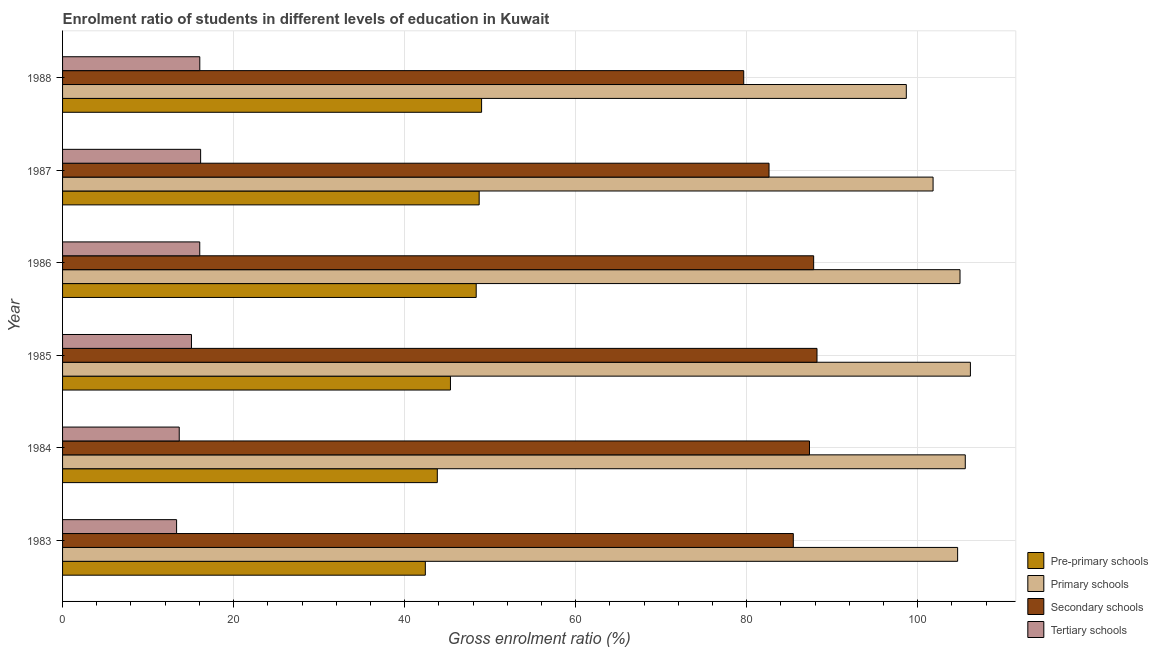How many different coloured bars are there?
Offer a terse response. 4. How many groups of bars are there?
Ensure brevity in your answer.  6. Are the number of bars per tick equal to the number of legend labels?
Give a very brief answer. Yes. What is the gross enrolment ratio in secondary schools in 1984?
Ensure brevity in your answer.  87.34. Across all years, what is the maximum gross enrolment ratio in pre-primary schools?
Your answer should be compact. 49. Across all years, what is the minimum gross enrolment ratio in secondary schools?
Offer a terse response. 79.65. In which year was the gross enrolment ratio in tertiary schools minimum?
Your response must be concise. 1983. What is the total gross enrolment ratio in tertiary schools in the graph?
Ensure brevity in your answer.  90.28. What is the difference between the gross enrolment ratio in tertiary schools in 1983 and that in 1985?
Your response must be concise. -1.74. What is the difference between the gross enrolment ratio in tertiary schools in 1985 and the gross enrolment ratio in secondary schools in 1983?
Provide a succinct answer. -70.38. What is the average gross enrolment ratio in secondary schools per year?
Offer a terse response. 85.18. In the year 1985, what is the difference between the gross enrolment ratio in primary schools and gross enrolment ratio in secondary schools?
Make the answer very short. 17.94. What is the ratio of the gross enrolment ratio in pre-primary schools in 1985 to that in 1986?
Give a very brief answer. 0.94. Is the gross enrolment ratio in secondary schools in 1985 less than that in 1986?
Ensure brevity in your answer.  No. Is the difference between the gross enrolment ratio in pre-primary schools in 1983 and 1988 greater than the difference between the gross enrolment ratio in primary schools in 1983 and 1988?
Offer a very short reply. No. What is the difference between the highest and the second highest gross enrolment ratio in tertiary schools?
Your answer should be very brief. 0.1. What is the difference between the highest and the lowest gross enrolment ratio in primary schools?
Your answer should be compact. 7.49. Is it the case that in every year, the sum of the gross enrolment ratio in secondary schools and gross enrolment ratio in pre-primary schools is greater than the sum of gross enrolment ratio in tertiary schools and gross enrolment ratio in primary schools?
Provide a short and direct response. No. What does the 4th bar from the top in 1986 represents?
Keep it short and to the point. Pre-primary schools. What does the 3rd bar from the bottom in 1987 represents?
Your answer should be very brief. Secondary schools. Is it the case that in every year, the sum of the gross enrolment ratio in pre-primary schools and gross enrolment ratio in primary schools is greater than the gross enrolment ratio in secondary schools?
Your answer should be compact. Yes. How many bars are there?
Your answer should be very brief. 24. Are all the bars in the graph horizontal?
Provide a short and direct response. Yes. Are the values on the major ticks of X-axis written in scientific E-notation?
Your answer should be compact. No. Does the graph contain grids?
Ensure brevity in your answer.  Yes. How are the legend labels stacked?
Your answer should be compact. Vertical. What is the title of the graph?
Your response must be concise. Enrolment ratio of students in different levels of education in Kuwait. What is the label or title of the X-axis?
Keep it short and to the point. Gross enrolment ratio (%). What is the Gross enrolment ratio (%) of Pre-primary schools in 1983?
Your answer should be very brief. 42.42. What is the Gross enrolment ratio (%) in Primary schools in 1983?
Provide a short and direct response. 104.66. What is the Gross enrolment ratio (%) in Secondary schools in 1983?
Make the answer very short. 85.45. What is the Gross enrolment ratio (%) in Tertiary schools in 1983?
Ensure brevity in your answer.  13.33. What is the Gross enrolment ratio (%) of Pre-primary schools in 1984?
Your answer should be very brief. 43.82. What is the Gross enrolment ratio (%) of Primary schools in 1984?
Provide a short and direct response. 105.56. What is the Gross enrolment ratio (%) in Secondary schools in 1984?
Ensure brevity in your answer.  87.34. What is the Gross enrolment ratio (%) in Tertiary schools in 1984?
Provide a short and direct response. 13.64. What is the Gross enrolment ratio (%) in Pre-primary schools in 1985?
Your answer should be very brief. 45.36. What is the Gross enrolment ratio (%) in Primary schools in 1985?
Make the answer very short. 106.16. What is the Gross enrolment ratio (%) of Secondary schools in 1985?
Offer a very short reply. 88.22. What is the Gross enrolment ratio (%) of Tertiary schools in 1985?
Ensure brevity in your answer.  15.07. What is the Gross enrolment ratio (%) of Pre-primary schools in 1986?
Your response must be concise. 48.37. What is the Gross enrolment ratio (%) in Primary schools in 1986?
Ensure brevity in your answer.  104.94. What is the Gross enrolment ratio (%) of Secondary schools in 1986?
Ensure brevity in your answer.  87.83. What is the Gross enrolment ratio (%) in Tertiary schools in 1986?
Keep it short and to the point. 16.04. What is the Gross enrolment ratio (%) in Pre-primary schools in 1987?
Your answer should be compact. 48.71. What is the Gross enrolment ratio (%) of Primary schools in 1987?
Your response must be concise. 101.79. What is the Gross enrolment ratio (%) in Secondary schools in 1987?
Your answer should be compact. 82.61. What is the Gross enrolment ratio (%) of Tertiary schools in 1987?
Give a very brief answer. 16.14. What is the Gross enrolment ratio (%) in Pre-primary schools in 1988?
Your answer should be very brief. 49. What is the Gross enrolment ratio (%) in Primary schools in 1988?
Your answer should be very brief. 98.66. What is the Gross enrolment ratio (%) of Secondary schools in 1988?
Provide a short and direct response. 79.65. What is the Gross enrolment ratio (%) in Tertiary schools in 1988?
Keep it short and to the point. 16.05. Across all years, what is the maximum Gross enrolment ratio (%) of Pre-primary schools?
Provide a succinct answer. 49. Across all years, what is the maximum Gross enrolment ratio (%) in Primary schools?
Your response must be concise. 106.16. Across all years, what is the maximum Gross enrolment ratio (%) of Secondary schools?
Your answer should be compact. 88.22. Across all years, what is the maximum Gross enrolment ratio (%) of Tertiary schools?
Your answer should be very brief. 16.14. Across all years, what is the minimum Gross enrolment ratio (%) of Pre-primary schools?
Make the answer very short. 42.42. Across all years, what is the minimum Gross enrolment ratio (%) of Primary schools?
Your answer should be compact. 98.66. Across all years, what is the minimum Gross enrolment ratio (%) of Secondary schools?
Your answer should be compact. 79.65. Across all years, what is the minimum Gross enrolment ratio (%) in Tertiary schools?
Give a very brief answer. 13.33. What is the total Gross enrolment ratio (%) of Pre-primary schools in the graph?
Make the answer very short. 277.68. What is the total Gross enrolment ratio (%) of Primary schools in the graph?
Keep it short and to the point. 621.77. What is the total Gross enrolment ratio (%) in Secondary schools in the graph?
Keep it short and to the point. 511.09. What is the total Gross enrolment ratio (%) of Tertiary schools in the graph?
Give a very brief answer. 90.28. What is the difference between the Gross enrolment ratio (%) of Pre-primary schools in 1983 and that in 1984?
Offer a terse response. -1.4. What is the difference between the Gross enrolment ratio (%) of Primary schools in 1983 and that in 1984?
Make the answer very short. -0.89. What is the difference between the Gross enrolment ratio (%) in Secondary schools in 1983 and that in 1984?
Provide a short and direct response. -1.89. What is the difference between the Gross enrolment ratio (%) in Tertiary schools in 1983 and that in 1984?
Ensure brevity in your answer.  -0.31. What is the difference between the Gross enrolment ratio (%) of Pre-primary schools in 1983 and that in 1985?
Provide a short and direct response. -2.94. What is the difference between the Gross enrolment ratio (%) of Primary schools in 1983 and that in 1985?
Your answer should be compact. -1.49. What is the difference between the Gross enrolment ratio (%) of Secondary schools in 1983 and that in 1985?
Your answer should be very brief. -2.77. What is the difference between the Gross enrolment ratio (%) in Tertiary schools in 1983 and that in 1985?
Give a very brief answer. -1.74. What is the difference between the Gross enrolment ratio (%) in Pre-primary schools in 1983 and that in 1986?
Provide a short and direct response. -5.95. What is the difference between the Gross enrolment ratio (%) in Primary schools in 1983 and that in 1986?
Keep it short and to the point. -0.28. What is the difference between the Gross enrolment ratio (%) of Secondary schools in 1983 and that in 1986?
Make the answer very short. -2.38. What is the difference between the Gross enrolment ratio (%) of Tertiary schools in 1983 and that in 1986?
Offer a very short reply. -2.71. What is the difference between the Gross enrolment ratio (%) of Pre-primary schools in 1983 and that in 1987?
Offer a very short reply. -6.29. What is the difference between the Gross enrolment ratio (%) of Primary schools in 1983 and that in 1987?
Offer a very short reply. 2.87. What is the difference between the Gross enrolment ratio (%) of Secondary schools in 1983 and that in 1987?
Keep it short and to the point. 2.84. What is the difference between the Gross enrolment ratio (%) of Tertiary schools in 1983 and that in 1987?
Ensure brevity in your answer.  -2.81. What is the difference between the Gross enrolment ratio (%) in Pre-primary schools in 1983 and that in 1988?
Your response must be concise. -6.58. What is the difference between the Gross enrolment ratio (%) of Primary schools in 1983 and that in 1988?
Provide a succinct answer. 6. What is the difference between the Gross enrolment ratio (%) in Secondary schools in 1983 and that in 1988?
Keep it short and to the point. 5.8. What is the difference between the Gross enrolment ratio (%) of Tertiary schools in 1983 and that in 1988?
Ensure brevity in your answer.  -2.71. What is the difference between the Gross enrolment ratio (%) of Pre-primary schools in 1984 and that in 1985?
Make the answer very short. -1.54. What is the difference between the Gross enrolment ratio (%) of Primary schools in 1984 and that in 1985?
Keep it short and to the point. -0.6. What is the difference between the Gross enrolment ratio (%) of Secondary schools in 1984 and that in 1985?
Provide a succinct answer. -0.88. What is the difference between the Gross enrolment ratio (%) of Tertiary schools in 1984 and that in 1985?
Your response must be concise. -1.43. What is the difference between the Gross enrolment ratio (%) of Pre-primary schools in 1984 and that in 1986?
Keep it short and to the point. -4.55. What is the difference between the Gross enrolment ratio (%) of Primary schools in 1984 and that in 1986?
Provide a short and direct response. 0.61. What is the difference between the Gross enrolment ratio (%) of Secondary schools in 1984 and that in 1986?
Ensure brevity in your answer.  -0.49. What is the difference between the Gross enrolment ratio (%) in Tertiary schools in 1984 and that in 1986?
Offer a terse response. -2.4. What is the difference between the Gross enrolment ratio (%) in Pre-primary schools in 1984 and that in 1987?
Your answer should be compact. -4.89. What is the difference between the Gross enrolment ratio (%) in Primary schools in 1984 and that in 1987?
Give a very brief answer. 3.76. What is the difference between the Gross enrolment ratio (%) in Secondary schools in 1984 and that in 1987?
Provide a short and direct response. 4.73. What is the difference between the Gross enrolment ratio (%) in Tertiary schools in 1984 and that in 1987?
Keep it short and to the point. -2.5. What is the difference between the Gross enrolment ratio (%) of Pre-primary schools in 1984 and that in 1988?
Your answer should be compact. -5.18. What is the difference between the Gross enrolment ratio (%) of Primary schools in 1984 and that in 1988?
Offer a terse response. 6.89. What is the difference between the Gross enrolment ratio (%) in Secondary schools in 1984 and that in 1988?
Provide a succinct answer. 7.69. What is the difference between the Gross enrolment ratio (%) of Tertiary schools in 1984 and that in 1988?
Provide a short and direct response. -2.4. What is the difference between the Gross enrolment ratio (%) in Pre-primary schools in 1985 and that in 1986?
Provide a short and direct response. -3.01. What is the difference between the Gross enrolment ratio (%) in Primary schools in 1985 and that in 1986?
Make the answer very short. 1.22. What is the difference between the Gross enrolment ratio (%) of Secondary schools in 1985 and that in 1986?
Offer a very short reply. 0.39. What is the difference between the Gross enrolment ratio (%) in Tertiary schools in 1985 and that in 1986?
Keep it short and to the point. -0.97. What is the difference between the Gross enrolment ratio (%) in Pre-primary schools in 1985 and that in 1987?
Your answer should be very brief. -3.36. What is the difference between the Gross enrolment ratio (%) in Primary schools in 1985 and that in 1987?
Your answer should be very brief. 4.36. What is the difference between the Gross enrolment ratio (%) of Secondary schools in 1985 and that in 1987?
Provide a short and direct response. 5.61. What is the difference between the Gross enrolment ratio (%) in Tertiary schools in 1985 and that in 1987?
Make the answer very short. -1.07. What is the difference between the Gross enrolment ratio (%) in Pre-primary schools in 1985 and that in 1988?
Make the answer very short. -3.64. What is the difference between the Gross enrolment ratio (%) in Primary schools in 1985 and that in 1988?
Provide a succinct answer. 7.49. What is the difference between the Gross enrolment ratio (%) of Secondary schools in 1985 and that in 1988?
Your answer should be compact. 8.57. What is the difference between the Gross enrolment ratio (%) of Tertiary schools in 1985 and that in 1988?
Keep it short and to the point. -0.97. What is the difference between the Gross enrolment ratio (%) in Pre-primary schools in 1986 and that in 1987?
Offer a very short reply. -0.35. What is the difference between the Gross enrolment ratio (%) in Primary schools in 1986 and that in 1987?
Keep it short and to the point. 3.15. What is the difference between the Gross enrolment ratio (%) of Secondary schools in 1986 and that in 1987?
Give a very brief answer. 5.22. What is the difference between the Gross enrolment ratio (%) of Tertiary schools in 1986 and that in 1987?
Provide a short and direct response. -0.1. What is the difference between the Gross enrolment ratio (%) in Pre-primary schools in 1986 and that in 1988?
Give a very brief answer. -0.63. What is the difference between the Gross enrolment ratio (%) in Primary schools in 1986 and that in 1988?
Ensure brevity in your answer.  6.28. What is the difference between the Gross enrolment ratio (%) of Secondary schools in 1986 and that in 1988?
Your answer should be very brief. 8.18. What is the difference between the Gross enrolment ratio (%) in Tertiary schools in 1986 and that in 1988?
Keep it short and to the point. -0.01. What is the difference between the Gross enrolment ratio (%) in Pre-primary schools in 1987 and that in 1988?
Make the answer very short. -0.28. What is the difference between the Gross enrolment ratio (%) in Primary schools in 1987 and that in 1988?
Provide a short and direct response. 3.13. What is the difference between the Gross enrolment ratio (%) in Secondary schools in 1987 and that in 1988?
Your answer should be very brief. 2.96. What is the difference between the Gross enrolment ratio (%) of Tertiary schools in 1987 and that in 1988?
Your answer should be compact. 0.1. What is the difference between the Gross enrolment ratio (%) of Pre-primary schools in 1983 and the Gross enrolment ratio (%) of Primary schools in 1984?
Your answer should be very brief. -63.14. What is the difference between the Gross enrolment ratio (%) in Pre-primary schools in 1983 and the Gross enrolment ratio (%) in Secondary schools in 1984?
Your answer should be compact. -44.92. What is the difference between the Gross enrolment ratio (%) of Pre-primary schools in 1983 and the Gross enrolment ratio (%) of Tertiary schools in 1984?
Provide a succinct answer. 28.78. What is the difference between the Gross enrolment ratio (%) of Primary schools in 1983 and the Gross enrolment ratio (%) of Secondary schools in 1984?
Make the answer very short. 17.32. What is the difference between the Gross enrolment ratio (%) of Primary schools in 1983 and the Gross enrolment ratio (%) of Tertiary schools in 1984?
Your answer should be compact. 91.02. What is the difference between the Gross enrolment ratio (%) in Secondary schools in 1983 and the Gross enrolment ratio (%) in Tertiary schools in 1984?
Keep it short and to the point. 71.8. What is the difference between the Gross enrolment ratio (%) of Pre-primary schools in 1983 and the Gross enrolment ratio (%) of Primary schools in 1985?
Provide a short and direct response. -63.74. What is the difference between the Gross enrolment ratio (%) in Pre-primary schools in 1983 and the Gross enrolment ratio (%) in Secondary schools in 1985?
Your response must be concise. -45.8. What is the difference between the Gross enrolment ratio (%) of Pre-primary schools in 1983 and the Gross enrolment ratio (%) of Tertiary schools in 1985?
Make the answer very short. 27.35. What is the difference between the Gross enrolment ratio (%) of Primary schools in 1983 and the Gross enrolment ratio (%) of Secondary schools in 1985?
Offer a very short reply. 16.44. What is the difference between the Gross enrolment ratio (%) of Primary schools in 1983 and the Gross enrolment ratio (%) of Tertiary schools in 1985?
Keep it short and to the point. 89.59. What is the difference between the Gross enrolment ratio (%) in Secondary schools in 1983 and the Gross enrolment ratio (%) in Tertiary schools in 1985?
Your answer should be compact. 70.38. What is the difference between the Gross enrolment ratio (%) in Pre-primary schools in 1983 and the Gross enrolment ratio (%) in Primary schools in 1986?
Keep it short and to the point. -62.52. What is the difference between the Gross enrolment ratio (%) of Pre-primary schools in 1983 and the Gross enrolment ratio (%) of Secondary schools in 1986?
Your response must be concise. -45.41. What is the difference between the Gross enrolment ratio (%) in Pre-primary schools in 1983 and the Gross enrolment ratio (%) in Tertiary schools in 1986?
Your answer should be compact. 26.38. What is the difference between the Gross enrolment ratio (%) of Primary schools in 1983 and the Gross enrolment ratio (%) of Secondary schools in 1986?
Ensure brevity in your answer.  16.84. What is the difference between the Gross enrolment ratio (%) of Primary schools in 1983 and the Gross enrolment ratio (%) of Tertiary schools in 1986?
Give a very brief answer. 88.62. What is the difference between the Gross enrolment ratio (%) in Secondary schools in 1983 and the Gross enrolment ratio (%) in Tertiary schools in 1986?
Give a very brief answer. 69.41. What is the difference between the Gross enrolment ratio (%) in Pre-primary schools in 1983 and the Gross enrolment ratio (%) in Primary schools in 1987?
Make the answer very short. -59.37. What is the difference between the Gross enrolment ratio (%) of Pre-primary schools in 1983 and the Gross enrolment ratio (%) of Secondary schools in 1987?
Keep it short and to the point. -40.19. What is the difference between the Gross enrolment ratio (%) of Pre-primary schools in 1983 and the Gross enrolment ratio (%) of Tertiary schools in 1987?
Provide a succinct answer. 26.28. What is the difference between the Gross enrolment ratio (%) in Primary schools in 1983 and the Gross enrolment ratio (%) in Secondary schools in 1987?
Keep it short and to the point. 22.05. What is the difference between the Gross enrolment ratio (%) in Primary schools in 1983 and the Gross enrolment ratio (%) in Tertiary schools in 1987?
Provide a short and direct response. 88.52. What is the difference between the Gross enrolment ratio (%) of Secondary schools in 1983 and the Gross enrolment ratio (%) of Tertiary schools in 1987?
Your answer should be very brief. 69.3. What is the difference between the Gross enrolment ratio (%) of Pre-primary schools in 1983 and the Gross enrolment ratio (%) of Primary schools in 1988?
Make the answer very short. -56.24. What is the difference between the Gross enrolment ratio (%) of Pre-primary schools in 1983 and the Gross enrolment ratio (%) of Secondary schools in 1988?
Give a very brief answer. -37.23. What is the difference between the Gross enrolment ratio (%) of Pre-primary schools in 1983 and the Gross enrolment ratio (%) of Tertiary schools in 1988?
Provide a short and direct response. 26.37. What is the difference between the Gross enrolment ratio (%) in Primary schools in 1983 and the Gross enrolment ratio (%) in Secondary schools in 1988?
Provide a short and direct response. 25.01. What is the difference between the Gross enrolment ratio (%) of Primary schools in 1983 and the Gross enrolment ratio (%) of Tertiary schools in 1988?
Make the answer very short. 88.62. What is the difference between the Gross enrolment ratio (%) of Secondary schools in 1983 and the Gross enrolment ratio (%) of Tertiary schools in 1988?
Your answer should be compact. 69.4. What is the difference between the Gross enrolment ratio (%) in Pre-primary schools in 1984 and the Gross enrolment ratio (%) in Primary schools in 1985?
Make the answer very short. -62.34. What is the difference between the Gross enrolment ratio (%) in Pre-primary schools in 1984 and the Gross enrolment ratio (%) in Secondary schools in 1985?
Ensure brevity in your answer.  -44.4. What is the difference between the Gross enrolment ratio (%) in Pre-primary schools in 1984 and the Gross enrolment ratio (%) in Tertiary schools in 1985?
Provide a short and direct response. 28.75. What is the difference between the Gross enrolment ratio (%) of Primary schools in 1984 and the Gross enrolment ratio (%) of Secondary schools in 1985?
Your answer should be compact. 17.34. What is the difference between the Gross enrolment ratio (%) in Primary schools in 1984 and the Gross enrolment ratio (%) in Tertiary schools in 1985?
Offer a terse response. 90.48. What is the difference between the Gross enrolment ratio (%) of Secondary schools in 1984 and the Gross enrolment ratio (%) of Tertiary schools in 1985?
Offer a very short reply. 72.27. What is the difference between the Gross enrolment ratio (%) of Pre-primary schools in 1984 and the Gross enrolment ratio (%) of Primary schools in 1986?
Ensure brevity in your answer.  -61.12. What is the difference between the Gross enrolment ratio (%) in Pre-primary schools in 1984 and the Gross enrolment ratio (%) in Secondary schools in 1986?
Your answer should be very brief. -44.01. What is the difference between the Gross enrolment ratio (%) in Pre-primary schools in 1984 and the Gross enrolment ratio (%) in Tertiary schools in 1986?
Provide a succinct answer. 27.78. What is the difference between the Gross enrolment ratio (%) of Primary schools in 1984 and the Gross enrolment ratio (%) of Secondary schools in 1986?
Your answer should be very brief. 17.73. What is the difference between the Gross enrolment ratio (%) of Primary schools in 1984 and the Gross enrolment ratio (%) of Tertiary schools in 1986?
Ensure brevity in your answer.  89.52. What is the difference between the Gross enrolment ratio (%) of Secondary schools in 1984 and the Gross enrolment ratio (%) of Tertiary schools in 1986?
Offer a very short reply. 71.3. What is the difference between the Gross enrolment ratio (%) in Pre-primary schools in 1984 and the Gross enrolment ratio (%) in Primary schools in 1987?
Make the answer very short. -57.97. What is the difference between the Gross enrolment ratio (%) of Pre-primary schools in 1984 and the Gross enrolment ratio (%) of Secondary schools in 1987?
Make the answer very short. -38.79. What is the difference between the Gross enrolment ratio (%) in Pre-primary schools in 1984 and the Gross enrolment ratio (%) in Tertiary schools in 1987?
Provide a short and direct response. 27.68. What is the difference between the Gross enrolment ratio (%) in Primary schools in 1984 and the Gross enrolment ratio (%) in Secondary schools in 1987?
Your answer should be very brief. 22.95. What is the difference between the Gross enrolment ratio (%) in Primary schools in 1984 and the Gross enrolment ratio (%) in Tertiary schools in 1987?
Your response must be concise. 89.41. What is the difference between the Gross enrolment ratio (%) in Secondary schools in 1984 and the Gross enrolment ratio (%) in Tertiary schools in 1987?
Your answer should be compact. 71.2. What is the difference between the Gross enrolment ratio (%) in Pre-primary schools in 1984 and the Gross enrolment ratio (%) in Primary schools in 1988?
Your answer should be compact. -54.84. What is the difference between the Gross enrolment ratio (%) of Pre-primary schools in 1984 and the Gross enrolment ratio (%) of Secondary schools in 1988?
Ensure brevity in your answer.  -35.83. What is the difference between the Gross enrolment ratio (%) in Pre-primary schools in 1984 and the Gross enrolment ratio (%) in Tertiary schools in 1988?
Provide a succinct answer. 27.77. What is the difference between the Gross enrolment ratio (%) in Primary schools in 1984 and the Gross enrolment ratio (%) in Secondary schools in 1988?
Offer a very short reply. 25.91. What is the difference between the Gross enrolment ratio (%) in Primary schools in 1984 and the Gross enrolment ratio (%) in Tertiary schools in 1988?
Provide a succinct answer. 89.51. What is the difference between the Gross enrolment ratio (%) in Secondary schools in 1984 and the Gross enrolment ratio (%) in Tertiary schools in 1988?
Your answer should be very brief. 71.29. What is the difference between the Gross enrolment ratio (%) in Pre-primary schools in 1985 and the Gross enrolment ratio (%) in Primary schools in 1986?
Your response must be concise. -59.59. What is the difference between the Gross enrolment ratio (%) in Pre-primary schools in 1985 and the Gross enrolment ratio (%) in Secondary schools in 1986?
Your response must be concise. -42.47. What is the difference between the Gross enrolment ratio (%) of Pre-primary schools in 1985 and the Gross enrolment ratio (%) of Tertiary schools in 1986?
Provide a succinct answer. 29.32. What is the difference between the Gross enrolment ratio (%) of Primary schools in 1985 and the Gross enrolment ratio (%) of Secondary schools in 1986?
Provide a short and direct response. 18.33. What is the difference between the Gross enrolment ratio (%) in Primary schools in 1985 and the Gross enrolment ratio (%) in Tertiary schools in 1986?
Offer a very short reply. 90.12. What is the difference between the Gross enrolment ratio (%) of Secondary schools in 1985 and the Gross enrolment ratio (%) of Tertiary schools in 1986?
Offer a terse response. 72.18. What is the difference between the Gross enrolment ratio (%) of Pre-primary schools in 1985 and the Gross enrolment ratio (%) of Primary schools in 1987?
Ensure brevity in your answer.  -56.44. What is the difference between the Gross enrolment ratio (%) of Pre-primary schools in 1985 and the Gross enrolment ratio (%) of Secondary schools in 1987?
Give a very brief answer. -37.25. What is the difference between the Gross enrolment ratio (%) in Pre-primary schools in 1985 and the Gross enrolment ratio (%) in Tertiary schools in 1987?
Offer a terse response. 29.21. What is the difference between the Gross enrolment ratio (%) in Primary schools in 1985 and the Gross enrolment ratio (%) in Secondary schools in 1987?
Provide a succinct answer. 23.55. What is the difference between the Gross enrolment ratio (%) of Primary schools in 1985 and the Gross enrolment ratio (%) of Tertiary schools in 1987?
Provide a short and direct response. 90.01. What is the difference between the Gross enrolment ratio (%) in Secondary schools in 1985 and the Gross enrolment ratio (%) in Tertiary schools in 1987?
Your answer should be compact. 72.07. What is the difference between the Gross enrolment ratio (%) of Pre-primary schools in 1985 and the Gross enrolment ratio (%) of Primary schools in 1988?
Keep it short and to the point. -53.31. What is the difference between the Gross enrolment ratio (%) of Pre-primary schools in 1985 and the Gross enrolment ratio (%) of Secondary schools in 1988?
Your answer should be compact. -34.29. What is the difference between the Gross enrolment ratio (%) of Pre-primary schools in 1985 and the Gross enrolment ratio (%) of Tertiary schools in 1988?
Keep it short and to the point. 29.31. What is the difference between the Gross enrolment ratio (%) in Primary schools in 1985 and the Gross enrolment ratio (%) in Secondary schools in 1988?
Offer a terse response. 26.51. What is the difference between the Gross enrolment ratio (%) of Primary schools in 1985 and the Gross enrolment ratio (%) of Tertiary schools in 1988?
Keep it short and to the point. 90.11. What is the difference between the Gross enrolment ratio (%) in Secondary schools in 1985 and the Gross enrolment ratio (%) in Tertiary schools in 1988?
Your response must be concise. 72.17. What is the difference between the Gross enrolment ratio (%) in Pre-primary schools in 1986 and the Gross enrolment ratio (%) in Primary schools in 1987?
Offer a very short reply. -53.42. What is the difference between the Gross enrolment ratio (%) in Pre-primary schools in 1986 and the Gross enrolment ratio (%) in Secondary schools in 1987?
Make the answer very short. -34.24. What is the difference between the Gross enrolment ratio (%) of Pre-primary schools in 1986 and the Gross enrolment ratio (%) of Tertiary schools in 1987?
Ensure brevity in your answer.  32.22. What is the difference between the Gross enrolment ratio (%) of Primary schools in 1986 and the Gross enrolment ratio (%) of Secondary schools in 1987?
Your response must be concise. 22.33. What is the difference between the Gross enrolment ratio (%) in Primary schools in 1986 and the Gross enrolment ratio (%) in Tertiary schools in 1987?
Give a very brief answer. 88.8. What is the difference between the Gross enrolment ratio (%) of Secondary schools in 1986 and the Gross enrolment ratio (%) of Tertiary schools in 1987?
Make the answer very short. 71.68. What is the difference between the Gross enrolment ratio (%) of Pre-primary schools in 1986 and the Gross enrolment ratio (%) of Primary schools in 1988?
Offer a terse response. -50.29. What is the difference between the Gross enrolment ratio (%) in Pre-primary schools in 1986 and the Gross enrolment ratio (%) in Secondary schools in 1988?
Offer a very short reply. -31.28. What is the difference between the Gross enrolment ratio (%) in Pre-primary schools in 1986 and the Gross enrolment ratio (%) in Tertiary schools in 1988?
Give a very brief answer. 32.32. What is the difference between the Gross enrolment ratio (%) of Primary schools in 1986 and the Gross enrolment ratio (%) of Secondary schools in 1988?
Ensure brevity in your answer.  25.29. What is the difference between the Gross enrolment ratio (%) of Primary schools in 1986 and the Gross enrolment ratio (%) of Tertiary schools in 1988?
Offer a very short reply. 88.89. What is the difference between the Gross enrolment ratio (%) of Secondary schools in 1986 and the Gross enrolment ratio (%) of Tertiary schools in 1988?
Offer a very short reply. 71.78. What is the difference between the Gross enrolment ratio (%) in Pre-primary schools in 1987 and the Gross enrolment ratio (%) in Primary schools in 1988?
Keep it short and to the point. -49.95. What is the difference between the Gross enrolment ratio (%) of Pre-primary schools in 1987 and the Gross enrolment ratio (%) of Secondary schools in 1988?
Ensure brevity in your answer.  -30.93. What is the difference between the Gross enrolment ratio (%) in Pre-primary schools in 1987 and the Gross enrolment ratio (%) in Tertiary schools in 1988?
Provide a short and direct response. 32.67. What is the difference between the Gross enrolment ratio (%) of Primary schools in 1987 and the Gross enrolment ratio (%) of Secondary schools in 1988?
Keep it short and to the point. 22.14. What is the difference between the Gross enrolment ratio (%) of Primary schools in 1987 and the Gross enrolment ratio (%) of Tertiary schools in 1988?
Offer a very short reply. 85.75. What is the difference between the Gross enrolment ratio (%) in Secondary schools in 1987 and the Gross enrolment ratio (%) in Tertiary schools in 1988?
Provide a short and direct response. 66.56. What is the average Gross enrolment ratio (%) in Pre-primary schools per year?
Provide a short and direct response. 46.28. What is the average Gross enrolment ratio (%) in Primary schools per year?
Your answer should be compact. 103.63. What is the average Gross enrolment ratio (%) of Secondary schools per year?
Provide a short and direct response. 85.18. What is the average Gross enrolment ratio (%) in Tertiary schools per year?
Give a very brief answer. 15.05. In the year 1983, what is the difference between the Gross enrolment ratio (%) of Pre-primary schools and Gross enrolment ratio (%) of Primary schools?
Offer a very short reply. -62.24. In the year 1983, what is the difference between the Gross enrolment ratio (%) in Pre-primary schools and Gross enrolment ratio (%) in Secondary schools?
Offer a very short reply. -43.03. In the year 1983, what is the difference between the Gross enrolment ratio (%) of Pre-primary schools and Gross enrolment ratio (%) of Tertiary schools?
Provide a short and direct response. 29.09. In the year 1983, what is the difference between the Gross enrolment ratio (%) of Primary schools and Gross enrolment ratio (%) of Secondary schools?
Your answer should be very brief. 19.21. In the year 1983, what is the difference between the Gross enrolment ratio (%) in Primary schools and Gross enrolment ratio (%) in Tertiary schools?
Provide a succinct answer. 91.33. In the year 1983, what is the difference between the Gross enrolment ratio (%) of Secondary schools and Gross enrolment ratio (%) of Tertiary schools?
Ensure brevity in your answer.  72.12. In the year 1984, what is the difference between the Gross enrolment ratio (%) in Pre-primary schools and Gross enrolment ratio (%) in Primary schools?
Offer a terse response. -61.74. In the year 1984, what is the difference between the Gross enrolment ratio (%) of Pre-primary schools and Gross enrolment ratio (%) of Secondary schools?
Give a very brief answer. -43.52. In the year 1984, what is the difference between the Gross enrolment ratio (%) of Pre-primary schools and Gross enrolment ratio (%) of Tertiary schools?
Make the answer very short. 30.18. In the year 1984, what is the difference between the Gross enrolment ratio (%) in Primary schools and Gross enrolment ratio (%) in Secondary schools?
Your response must be concise. 18.22. In the year 1984, what is the difference between the Gross enrolment ratio (%) in Primary schools and Gross enrolment ratio (%) in Tertiary schools?
Offer a terse response. 91.91. In the year 1984, what is the difference between the Gross enrolment ratio (%) in Secondary schools and Gross enrolment ratio (%) in Tertiary schools?
Provide a short and direct response. 73.7. In the year 1985, what is the difference between the Gross enrolment ratio (%) in Pre-primary schools and Gross enrolment ratio (%) in Primary schools?
Your response must be concise. -60.8. In the year 1985, what is the difference between the Gross enrolment ratio (%) of Pre-primary schools and Gross enrolment ratio (%) of Secondary schools?
Your response must be concise. -42.86. In the year 1985, what is the difference between the Gross enrolment ratio (%) of Pre-primary schools and Gross enrolment ratio (%) of Tertiary schools?
Provide a succinct answer. 30.28. In the year 1985, what is the difference between the Gross enrolment ratio (%) of Primary schools and Gross enrolment ratio (%) of Secondary schools?
Your answer should be very brief. 17.94. In the year 1985, what is the difference between the Gross enrolment ratio (%) of Primary schools and Gross enrolment ratio (%) of Tertiary schools?
Offer a very short reply. 91.08. In the year 1985, what is the difference between the Gross enrolment ratio (%) of Secondary schools and Gross enrolment ratio (%) of Tertiary schools?
Ensure brevity in your answer.  73.14. In the year 1986, what is the difference between the Gross enrolment ratio (%) in Pre-primary schools and Gross enrolment ratio (%) in Primary schools?
Give a very brief answer. -56.57. In the year 1986, what is the difference between the Gross enrolment ratio (%) in Pre-primary schools and Gross enrolment ratio (%) in Secondary schools?
Give a very brief answer. -39.46. In the year 1986, what is the difference between the Gross enrolment ratio (%) of Pre-primary schools and Gross enrolment ratio (%) of Tertiary schools?
Offer a very short reply. 32.33. In the year 1986, what is the difference between the Gross enrolment ratio (%) in Primary schools and Gross enrolment ratio (%) in Secondary schools?
Keep it short and to the point. 17.12. In the year 1986, what is the difference between the Gross enrolment ratio (%) of Primary schools and Gross enrolment ratio (%) of Tertiary schools?
Provide a short and direct response. 88.9. In the year 1986, what is the difference between the Gross enrolment ratio (%) in Secondary schools and Gross enrolment ratio (%) in Tertiary schools?
Offer a terse response. 71.79. In the year 1987, what is the difference between the Gross enrolment ratio (%) of Pre-primary schools and Gross enrolment ratio (%) of Primary schools?
Offer a very short reply. -53.08. In the year 1987, what is the difference between the Gross enrolment ratio (%) of Pre-primary schools and Gross enrolment ratio (%) of Secondary schools?
Give a very brief answer. -33.9. In the year 1987, what is the difference between the Gross enrolment ratio (%) of Pre-primary schools and Gross enrolment ratio (%) of Tertiary schools?
Make the answer very short. 32.57. In the year 1987, what is the difference between the Gross enrolment ratio (%) of Primary schools and Gross enrolment ratio (%) of Secondary schools?
Offer a terse response. 19.18. In the year 1987, what is the difference between the Gross enrolment ratio (%) of Primary schools and Gross enrolment ratio (%) of Tertiary schools?
Your answer should be very brief. 85.65. In the year 1987, what is the difference between the Gross enrolment ratio (%) in Secondary schools and Gross enrolment ratio (%) in Tertiary schools?
Your answer should be compact. 66.47. In the year 1988, what is the difference between the Gross enrolment ratio (%) of Pre-primary schools and Gross enrolment ratio (%) of Primary schools?
Offer a very short reply. -49.66. In the year 1988, what is the difference between the Gross enrolment ratio (%) in Pre-primary schools and Gross enrolment ratio (%) in Secondary schools?
Provide a succinct answer. -30.65. In the year 1988, what is the difference between the Gross enrolment ratio (%) of Pre-primary schools and Gross enrolment ratio (%) of Tertiary schools?
Provide a succinct answer. 32.95. In the year 1988, what is the difference between the Gross enrolment ratio (%) in Primary schools and Gross enrolment ratio (%) in Secondary schools?
Make the answer very short. 19.01. In the year 1988, what is the difference between the Gross enrolment ratio (%) in Primary schools and Gross enrolment ratio (%) in Tertiary schools?
Make the answer very short. 82.62. In the year 1988, what is the difference between the Gross enrolment ratio (%) in Secondary schools and Gross enrolment ratio (%) in Tertiary schools?
Keep it short and to the point. 63.6. What is the ratio of the Gross enrolment ratio (%) of Pre-primary schools in 1983 to that in 1984?
Your answer should be very brief. 0.97. What is the ratio of the Gross enrolment ratio (%) of Secondary schools in 1983 to that in 1984?
Your answer should be compact. 0.98. What is the ratio of the Gross enrolment ratio (%) of Tertiary schools in 1983 to that in 1984?
Your answer should be compact. 0.98. What is the ratio of the Gross enrolment ratio (%) of Pre-primary schools in 1983 to that in 1985?
Ensure brevity in your answer.  0.94. What is the ratio of the Gross enrolment ratio (%) of Primary schools in 1983 to that in 1985?
Ensure brevity in your answer.  0.99. What is the ratio of the Gross enrolment ratio (%) of Secondary schools in 1983 to that in 1985?
Your answer should be compact. 0.97. What is the ratio of the Gross enrolment ratio (%) in Tertiary schools in 1983 to that in 1985?
Your answer should be very brief. 0.88. What is the ratio of the Gross enrolment ratio (%) in Pre-primary schools in 1983 to that in 1986?
Provide a short and direct response. 0.88. What is the ratio of the Gross enrolment ratio (%) in Secondary schools in 1983 to that in 1986?
Make the answer very short. 0.97. What is the ratio of the Gross enrolment ratio (%) in Tertiary schools in 1983 to that in 1986?
Your answer should be very brief. 0.83. What is the ratio of the Gross enrolment ratio (%) of Pre-primary schools in 1983 to that in 1987?
Provide a short and direct response. 0.87. What is the ratio of the Gross enrolment ratio (%) in Primary schools in 1983 to that in 1987?
Make the answer very short. 1.03. What is the ratio of the Gross enrolment ratio (%) of Secondary schools in 1983 to that in 1987?
Make the answer very short. 1.03. What is the ratio of the Gross enrolment ratio (%) in Tertiary schools in 1983 to that in 1987?
Your answer should be very brief. 0.83. What is the ratio of the Gross enrolment ratio (%) of Pre-primary schools in 1983 to that in 1988?
Provide a succinct answer. 0.87. What is the ratio of the Gross enrolment ratio (%) in Primary schools in 1983 to that in 1988?
Ensure brevity in your answer.  1.06. What is the ratio of the Gross enrolment ratio (%) in Secondary schools in 1983 to that in 1988?
Provide a short and direct response. 1.07. What is the ratio of the Gross enrolment ratio (%) of Tertiary schools in 1983 to that in 1988?
Offer a terse response. 0.83. What is the ratio of the Gross enrolment ratio (%) of Pre-primary schools in 1984 to that in 1985?
Offer a very short reply. 0.97. What is the ratio of the Gross enrolment ratio (%) in Tertiary schools in 1984 to that in 1985?
Provide a succinct answer. 0.91. What is the ratio of the Gross enrolment ratio (%) of Pre-primary schools in 1984 to that in 1986?
Provide a short and direct response. 0.91. What is the ratio of the Gross enrolment ratio (%) of Primary schools in 1984 to that in 1986?
Your answer should be very brief. 1.01. What is the ratio of the Gross enrolment ratio (%) in Secondary schools in 1984 to that in 1986?
Your answer should be very brief. 0.99. What is the ratio of the Gross enrolment ratio (%) of Tertiary schools in 1984 to that in 1986?
Offer a terse response. 0.85. What is the ratio of the Gross enrolment ratio (%) of Pre-primary schools in 1984 to that in 1987?
Make the answer very short. 0.9. What is the ratio of the Gross enrolment ratio (%) of Primary schools in 1984 to that in 1987?
Give a very brief answer. 1.04. What is the ratio of the Gross enrolment ratio (%) of Secondary schools in 1984 to that in 1987?
Offer a terse response. 1.06. What is the ratio of the Gross enrolment ratio (%) of Tertiary schools in 1984 to that in 1987?
Provide a short and direct response. 0.85. What is the ratio of the Gross enrolment ratio (%) of Pre-primary schools in 1984 to that in 1988?
Offer a terse response. 0.89. What is the ratio of the Gross enrolment ratio (%) in Primary schools in 1984 to that in 1988?
Offer a terse response. 1.07. What is the ratio of the Gross enrolment ratio (%) of Secondary schools in 1984 to that in 1988?
Keep it short and to the point. 1.1. What is the ratio of the Gross enrolment ratio (%) in Tertiary schools in 1984 to that in 1988?
Make the answer very short. 0.85. What is the ratio of the Gross enrolment ratio (%) in Pre-primary schools in 1985 to that in 1986?
Provide a short and direct response. 0.94. What is the ratio of the Gross enrolment ratio (%) of Primary schools in 1985 to that in 1986?
Provide a succinct answer. 1.01. What is the ratio of the Gross enrolment ratio (%) of Secondary schools in 1985 to that in 1986?
Provide a succinct answer. 1. What is the ratio of the Gross enrolment ratio (%) in Tertiary schools in 1985 to that in 1986?
Offer a very short reply. 0.94. What is the ratio of the Gross enrolment ratio (%) of Pre-primary schools in 1985 to that in 1987?
Keep it short and to the point. 0.93. What is the ratio of the Gross enrolment ratio (%) in Primary schools in 1985 to that in 1987?
Keep it short and to the point. 1.04. What is the ratio of the Gross enrolment ratio (%) of Secondary schools in 1985 to that in 1987?
Make the answer very short. 1.07. What is the ratio of the Gross enrolment ratio (%) in Tertiary schools in 1985 to that in 1987?
Give a very brief answer. 0.93. What is the ratio of the Gross enrolment ratio (%) of Pre-primary schools in 1985 to that in 1988?
Offer a terse response. 0.93. What is the ratio of the Gross enrolment ratio (%) of Primary schools in 1985 to that in 1988?
Offer a terse response. 1.08. What is the ratio of the Gross enrolment ratio (%) in Secondary schools in 1985 to that in 1988?
Your response must be concise. 1.11. What is the ratio of the Gross enrolment ratio (%) in Tertiary schools in 1985 to that in 1988?
Your answer should be compact. 0.94. What is the ratio of the Gross enrolment ratio (%) of Pre-primary schools in 1986 to that in 1987?
Give a very brief answer. 0.99. What is the ratio of the Gross enrolment ratio (%) of Primary schools in 1986 to that in 1987?
Your response must be concise. 1.03. What is the ratio of the Gross enrolment ratio (%) in Secondary schools in 1986 to that in 1987?
Offer a terse response. 1.06. What is the ratio of the Gross enrolment ratio (%) of Pre-primary schools in 1986 to that in 1988?
Provide a succinct answer. 0.99. What is the ratio of the Gross enrolment ratio (%) of Primary schools in 1986 to that in 1988?
Your answer should be very brief. 1.06. What is the ratio of the Gross enrolment ratio (%) in Secondary schools in 1986 to that in 1988?
Give a very brief answer. 1.1. What is the ratio of the Gross enrolment ratio (%) in Pre-primary schools in 1987 to that in 1988?
Your answer should be very brief. 0.99. What is the ratio of the Gross enrolment ratio (%) in Primary schools in 1987 to that in 1988?
Your answer should be compact. 1.03. What is the ratio of the Gross enrolment ratio (%) in Secondary schools in 1987 to that in 1988?
Keep it short and to the point. 1.04. What is the ratio of the Gross enrolment ratio (%) in Tertiary schools in 1987 to that in 1988?
Make the answer very short. 1.01. What is the difference between the highest and the second highest Gross enrolment ratio (%) in Pre-primary schools?
Give a very brief answer. 0.28. What is the difference between the highest and the second highest Gross enrolment ratio (%) in Primary schools?
Your answer should be compact. 0.6. What is the difference between the highest and the second highest Gross enrolment ratio (%) in Secondary schools?
Make the answer very short. 0.39. What is the difference between the highest and the second highest Gross enrolment ratio (%) of Tertiary schools?
Give a very brief answer. 0.1. What is the difference between the highest and the lowest Gross enrolment ratio (%) of Pre-primary schools?
Your response must be concise. 6.58. What is the difference between the highest and the lowest Gross enrolment ratio (%) in Primary schools?
Offer a very short reply. 7.49. What is the difference between the highest and the lowest Gross enrolment ratio (%) in Secondary schools?
Keep it short and to the point. 8.57. What is the difference between the highest and the lowest Gross enrolment ratio (%) in Tertiary schools?
Provide a succinct answer. 2.81. 